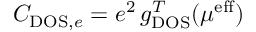<formula> <loc_0><loc_0><loc_500><loc_500>C _ { D O S , e } = e ^ { 2 } \, g _ { D O S } ^ { T } ( \mu ^ { e f f } )</formula> 